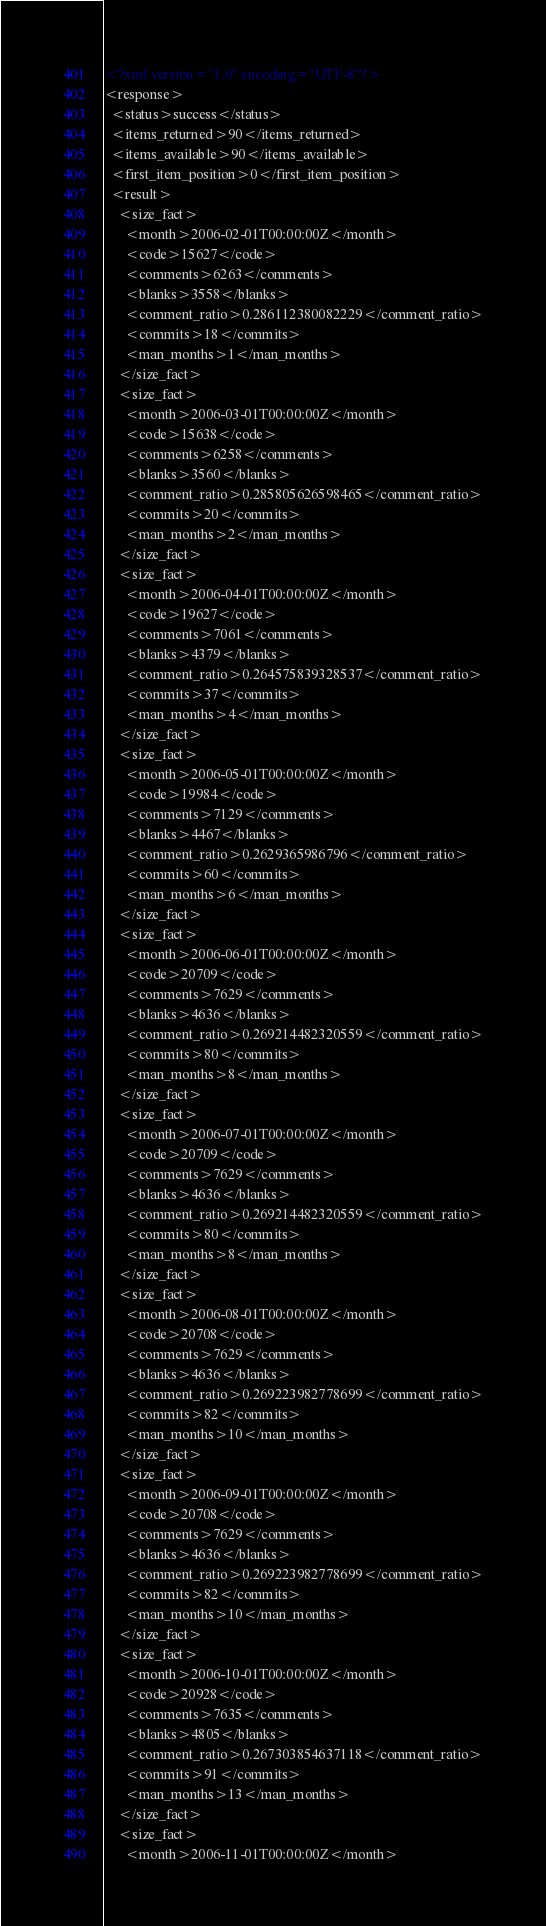<code> <loc_0><loc_0><loc_500><loc_500><_XML_><?xml version="1.0" encoding="UTF-8"?>
<response>
  <status>success</status>
  <items_returned>90</items_returned>
  <items_available>90</items_available>
  <first_item_position>0</first_item_position>
  <result>
    <size_fact>
      <month>2006-02-01T00:00:00Z</month>
      <code>15627</code>
      <comments>6263</comments>
      <blanks>3558</blanks>
      <comment_ratio>0.286112380082229</comment_ratio>
      <commits>18</commits>
      <man_months>1</man_months>
    </size_fact>
    <size_fact>
      <month>2006-03-01T00:00:00Z</month>
      <code>15638</code>
      <comments>6258</comments>
      <blanks>3560</blanks>
      <comment_ratio>0.285805626598465</comment_ratio>
      <commits>20</commits>
      <man_months>2</man_months>
    </size_fact>
    <size_fact>
      <month>2006-04-01T00:00:00Z</month>
      <code>19627</code>
      <comments>7061</comments>
      <blanks>4379</blanks>
      <comment_ratio>0.264575839328537</comment_ratio>
      <commits>37</commits>
      <man_months>4</man_months>
    </size_fact>
    <size_fact>
      <month>2006-05-01T00:00:00Z</month>
      <code>19984</code>
      <comments>7129</comments>
      <blanks>4467</blanks>
      <comment_ratio>0.2629365986796</comment_ratio>
      <commits>60</commits>
      <man_months>6</man_months>
    </size_fact>
    <size_fact>
      <month>2006-06-01T00:00:00Z</month>
      <code>20709</code>
      <comments>7629</comments>
      <blanks>4636</blanks>
      <comment_ratio>0.269214482320559</comment_ratio>
      <commits>80</commits>
      <man_months>8</man_months>
    </size_fact>
    <size_fact>
      <month>2006-07-01T00:00:00Z</month>
      <code>20709</code>
      <comments>7629</comments>
      <blanks>4636</blanks>
      <comment_ratio>0.269214482320559</comment_ratio>
      <commits>80</commits>
      <man_months>8</man_months>
    </size_fact>
    <size_fact>
      <month>2006-08-01T00:00:00Z</month>
      <code>20708</code>
      <comments>7629</comments>
      <blanks>4636</blanks>
      <comment_ratio>0.269223982778699</comment_ratio>
      <commits>82</commits>
      <man_months>10</man_months>
    </size_fact>
    <size_fact>
      <month>2006-09-01T00:00:00Z</month>
      <code>20708</code>
      <comments>7629</comments>
      <blanks>4636</blanks>
      <comment_ratio>0.269223982778699</comment_ratio>
      <commits>82</commits>
      <man_months>10</man_months>
    </size_fact>
    <size_fact>
      <month>2006-10-01T00:00:00Z</month>
      <code>20928</code>
      <comments>7635</comments>
      <blanks>4805</blanks>
      <comment_ratio>0.267303854637118</comment_ratio>
      <commits>91</commits>
      <man_months>13</man_months>
    </size_fact>
    <size_fact>
      <month>2006-11-01T00:00:00Z</month></code> 